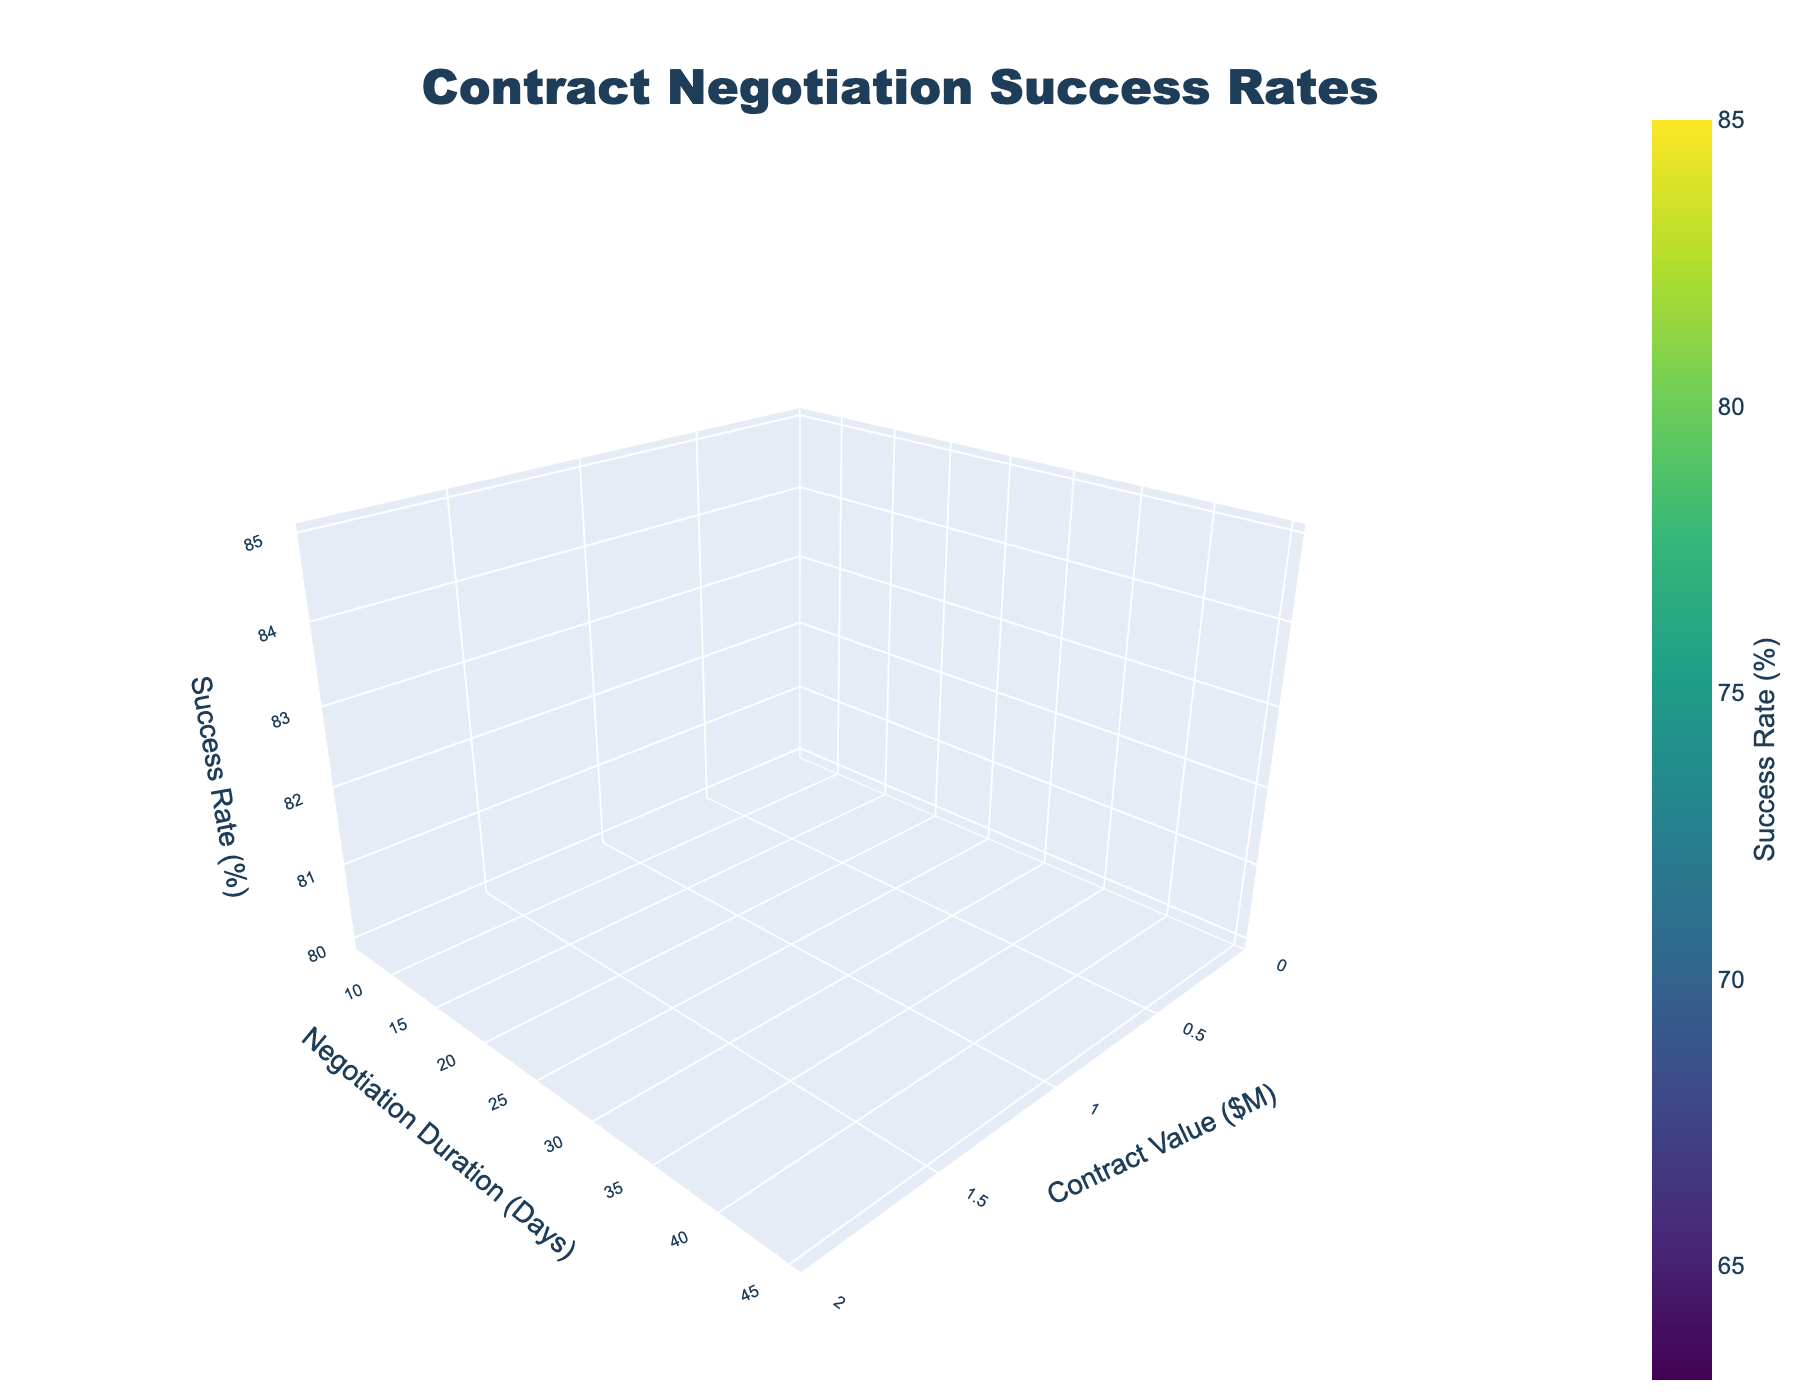What's the title of the plot? The title of the plot is displayed at the top center and reads 'Contract Negotiation Success Rates'.
Answer: Contract Negotiation Success Rates What's the color scheme used in the plot? The colors on the surface plot range from yellow to green to dark blue, indicating a Viridis color scale.
Answer: Viridis Which axis represents Contract Value? The x-axis represents the Contract Value, measured in millions of dollars ($M).
Answer: x-axis How is the Success Rate distributed as the Contract Value increases within the Technology industry? Observing the surface plot for the Technology industry section, the Success Rate decreases as the Contract Value increases.
Answer: Decreases What's the effect of increasing Negotiation Duration on the Success Rate for Healthcare contracts? Within the Healthcare industry section, the Success Rate decreases as the Negotiation Duration increases.
Answer: Decreases What Contract Values appear to have the highest Success Rates across all industries? By looking at the peaks in the surface for all industry sections, Contract Values of $1M have the highest Success Rates.
Answer: $1M Can you identify any trends in the Success Rate based on Negotiation Duration across different industries? For almost all industries, the Success Rate generally decreases as Negotiation Duration increases.
Answer: Decreases Which industry has the highest Success Rate for a $50M Contract Value? The surface corresponding to Healthcare has the highest peak for $50M Contract Value, indicating that Healthcare has the highest Success Rate for $50M contracts.
Answer: Healthcare Is the duration of the camera in 3D space affecting the aspect of the plot? The camera's eye is positioned such that the 3D plot allows proper viewing of the surface and aspect ratios, giving a balanced view of all parameters.
Answer: Balanced View 